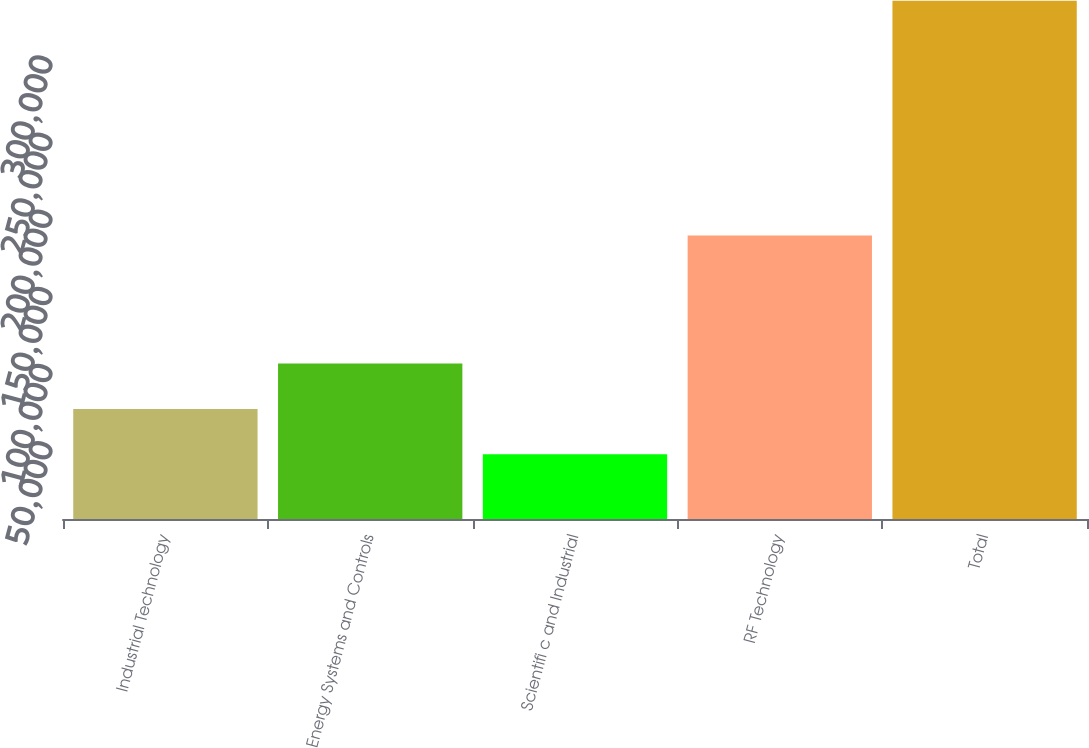Convert chart to OTSL. <chart><loc_0><loc_0><loc_500><loc_500><bar_chart><fcel>Industrial Technology<fcel>Energy Systems and Controls<fcel>Scientifi c and Industrial<fcel>RF Technology<fcel>Total<nl><fcel>71373.3<fcel>100773<fcel>41974<fcel>183742<fcel>335967<nl></chart> 